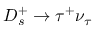Convert formula to latex. <formula><loc_0><loc_0><loc_500><loc_500>D _ { s } ^ { + } \to \tau ^ { + } \nu _ { \tau }</formula> 